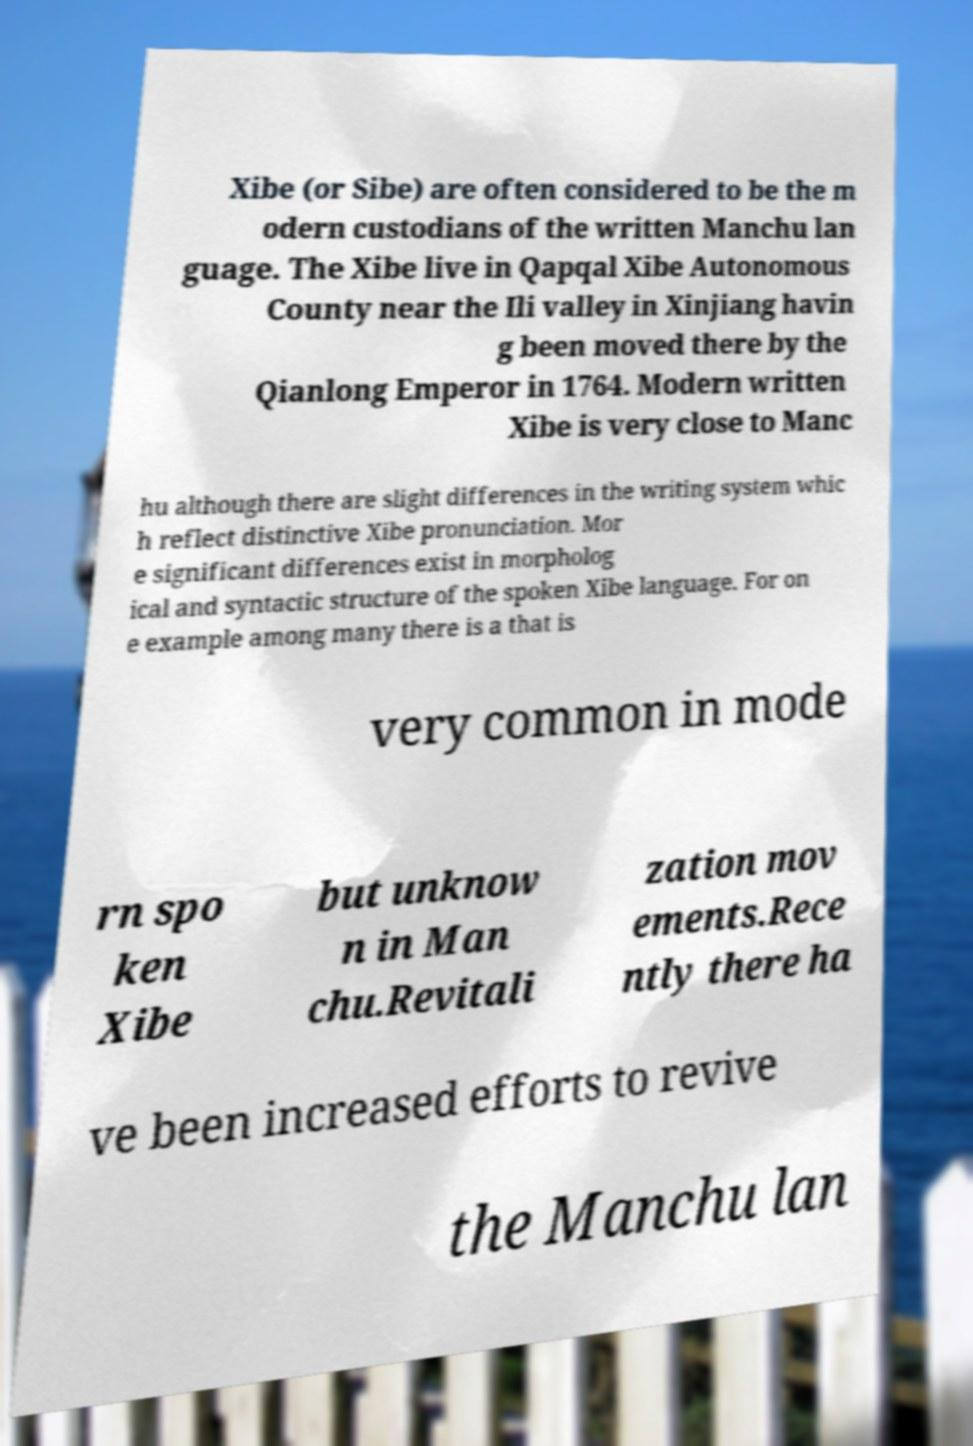Can you accurately transcribe the text from the provided image for me? Xibe (or Sibe) are often considered to be the m odern custodians of the written Manchu lan guage. The Xibe live in Qapqal Xibe Autonomous County near the Ili valley in Xinjiang havin g been moved there by the Qianlong Emperor in 1764. Modern written Xibe is very close to Manc hu although there are slight differences in the writing system whic h reflect distinctive Xibe pronunciation. Mor e significant differences exist in morpholog ical and syntactic structure of the spoken Xibe language. For on e example among many there is a that is very common in mode rn spo ken Xibe but unknow n in Man chu.Revitali zation mov ements.Rece ntly there ha ve been increased efforts to revive the Manchu lan 